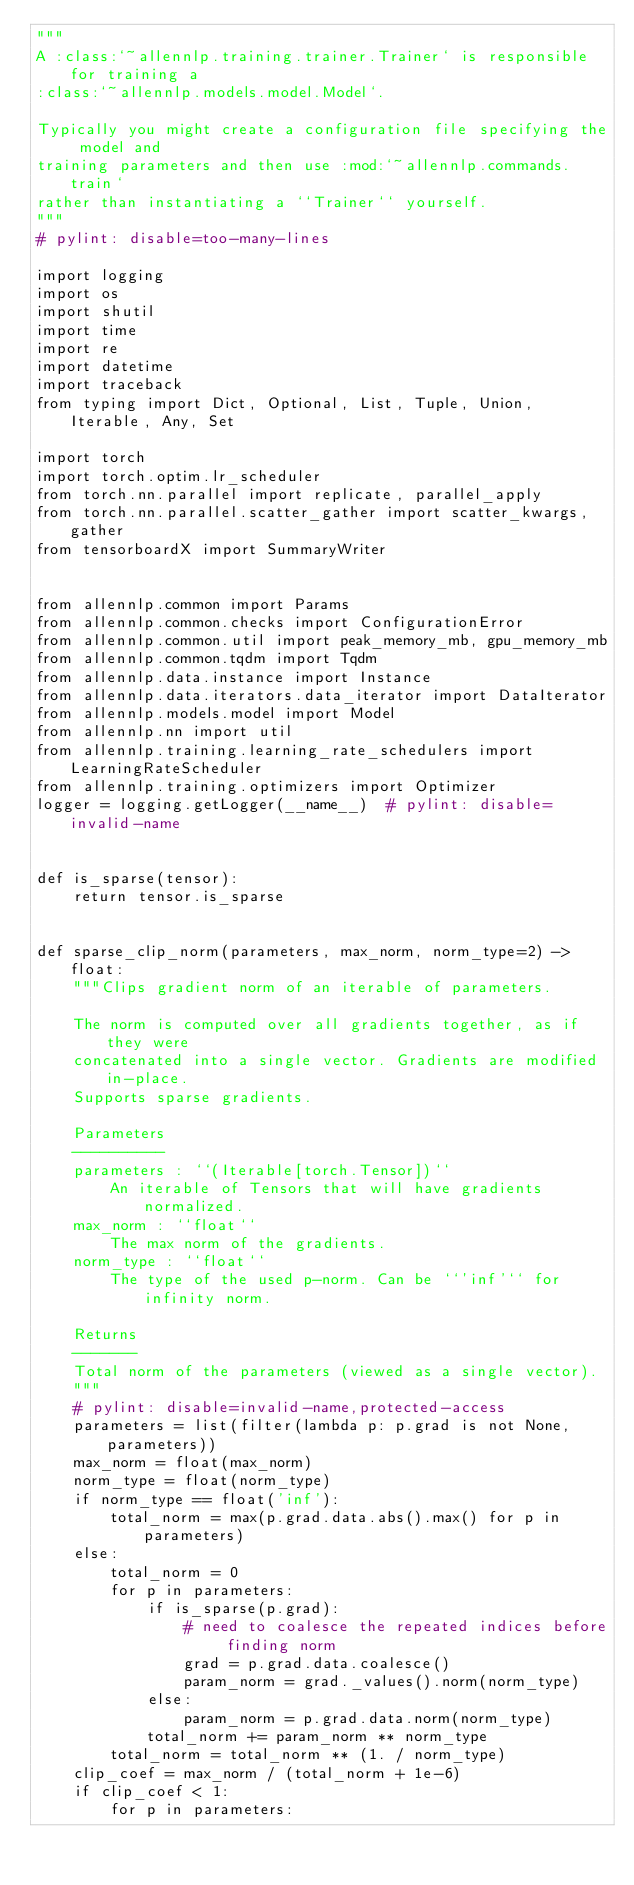<code> <loc_0><loc_0><loc_500><loc_500><_Python_>"""
A :class:`~allennlp.training.trainer.Trainer` is responsible for training a
:class:`~allennlp.models.model.Model`.

Typically you might create a configuration file specifying the model and
training parameters and then use :mod:`~allennlp.commands.train`
rather than instantiating a ``Trainer`` yourself.
"""
# pylint: disable=too-many-lines

import logging
import os
import shutil
import time
import re
import datetime
import traceback
from typing import Dict, Optional, List, Tuple, Union, Iterable, Any, Set

import torch
import torch.optim.lr_scheduler
from torch.nn.parallel import replicate, parallel_apply
from torch.nn.parallel.scatter_gather import scatter_kwargs, gather
from tensorboardX import SummaryWriter


from allennlp.common import Params
from allennlp.common.checks import ConfigurationError
from allennlp.common.util import peak_memory_mb, gpu_memory_mb
from allennlp.common.tqdm import Tqdm
from allennlp.data.instance import Instance
from allennlp.data.iterators.data_iterator import DataIterator
from allennlp.models.model import Model
from allennlp.nn import util
from allennlp.training.learning_rate_schedulers import LearningRateScheduler
from allennlp.training.optimizers import Optimizer
logger = logging.getLogger(__name__)  # pylint: disable=invalid-name


def is_sparse(tensor):
    return tensor.is_sparse


def sparse_clip_norm(parameters, max_norm, norm_type=2) -> float:
    """Clips gradient norm of an iterable of parameters.

    The norm is computed over all gradients together, as if they were
    concatenated into a single vector. Gradients are modified in-place.
    Supports sparse gradients.

    Parameters
    ----------
    parameters : ``(Iterable[torch.Tensor])``
        An iterable of Tensors that will have gradients normalized.
    max_norm : ``float``
        The max norm of the gradients.
    norm_type : ``float``
        The type of the used p-norm. Can be ``'inf'`` for infinity norm.

    Returns
    -------
    Total norm of the parameters (viewed as a single vector).
    """
    # pylint: disable=invalid-name,protected-access
    parameters = list(filter(lambda p: p.grad is not None, parameters))
    max_norm = float(max_norm)
    norm_type = float(norm_type)
    if norm_type == float('inf'):
        total_norm = max(p.grad.data.abs().max() for p in parameters)
    else:
        total_norm = 0
        for p in parameters:
            if is_sparse(p.grad):
                # need to coalesce the repeated indices before finding norm
                grad = p.grad.data.coalesce()
                param_norm = grad._values().norm(norm_type)
            else:
                param_norm = p.grad.data.norm(norm_type)
            total_norm += param_norm ** norm_type
        total_norm = total_norm ** (1. / norm_type)
    clip_coef = max_norm / (total_norm + 1e-6)
    if clip_coef < 1:
        for p in parameters:</code> 